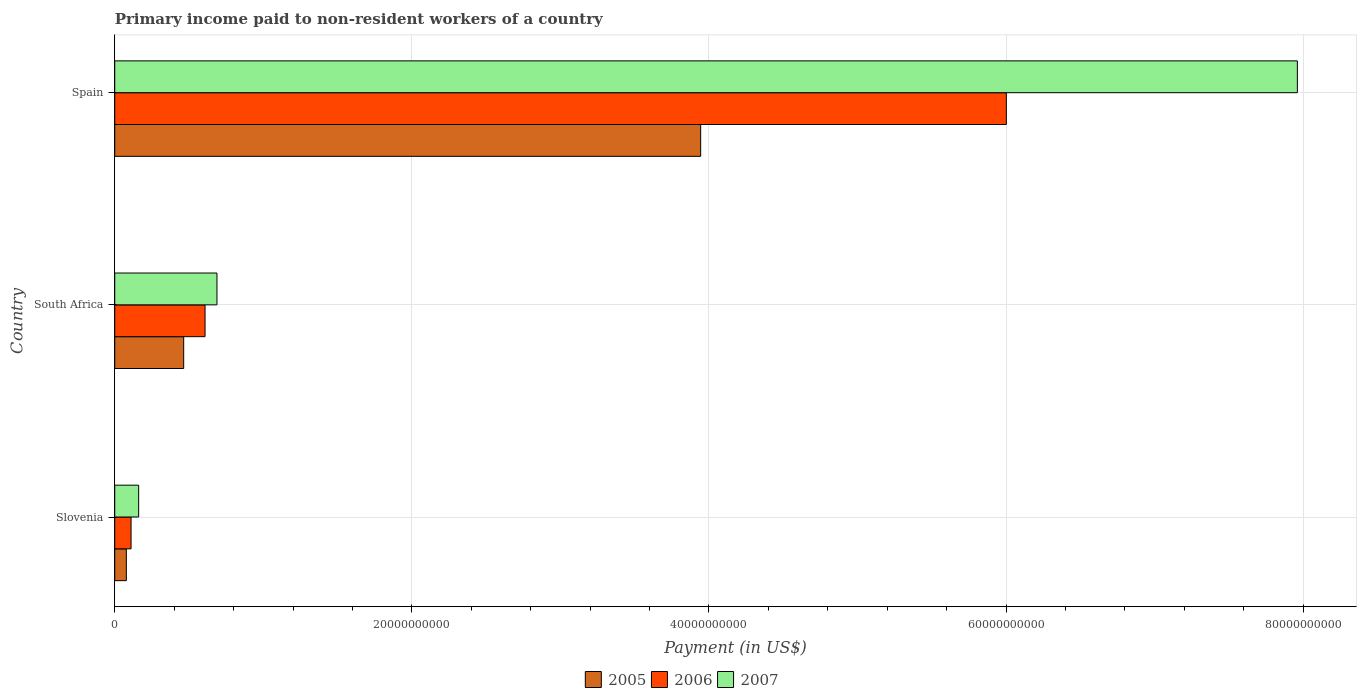How many different coloured bars are there?
Your answer should be very brief. 3. How many groups of bars are there?
Your answer should be very brief. 3. Are the number of bars per tick equal to the number of legend labels?
Offer a terse response. Yes. How many bars are there on the 3rd tick from the top?
Provide a succinct answer. 3. How many bars are there on the 3rd tick from the bottom?
Keep it short and to the point. 3. What is the label of the 2nd group of bars from the top?
Give a very brief answer. South Africa. What is the amount paid to workers in 2005 in South Africa?
Offer a terse response. 4.64e+09. Across all countries, what is the maximum amount paid to workers in 2007?
Keep it short and to the point. 7.96e+1. Across all countries, what is the minimum amount paid to workers in 2007?
Provide a short and direct response. 1.61e+09. In which country was the amount paid to workers in 2007 maximum?
Offer a very short reply. Spain. In which country was the amount paid to workers in 2006 minimum?
Ensure brevity in your answer.  Slovenia. What is the total amount paid to workers in 2005 in the graph?
Offer a very short reply. 4.49e+1. What is the difference between the amount paid to workers in 2005 in Slovenia and that in South Africa?
Your response must be concise. -3.86e+09. What is the difference between the amount paid to workers in 2005 in Spain and the amount paid to workers in 2007 in South Africa?
Give a very brief answer. 3.26e+1. What is the average amount paid to workers in 2006 per country?
Ensure brevity in your answer.  2.24e+1. What is the difference between the amount paid to workers in 2006 and amount paid to workers in 2005 in South Africa?
Keep it short and to the point. 1.44e+09. What is the ratio of the amount paid to workers in 2007 in Slovenia to that in Spain?
Provide a succinct answer. 0.02. Is the amount paid to workers in 2007 in South Africa less than that in Spain?
Your answer should be compact. Yes. What is the difference between the highest and the second highest amount paid to workers in 2005?
Offer a very short reply. 3.48e+1. What is the difference between the highest and the lowest amount paid to workers in 2006?
Your response must be concise. 5.89e+1. Is it the case that in every country, the sum of the amount paid to workers in 2006 and amount paid to workers in 2007 is greater than the amount paid to workers in 2005?
Keep it short and to the point. Yes. How many countries are there in the graph?
Provide a succinct answer. 3. Are the values on the major ticks of X-axis written in scientific E-notation?
Make the answer very short. No. Does the graph contain any zero values?
Your answer should be compact. No. How many legend labels are there?
Your response must be concise. 3. What is the title of the graph?
Give a very brief answer. Primary income paid to non-resident workers of a country. What is the label or title of the X-axis?
Your answer should be compact. Payment (in US$). What is the label or title of the Y-axis?
Keep it short and to the point. Country. What is the Payment (in US$) of 2005 in Slovenia?
Give a very brief answer. 7.81e+08. What is the Payment (in US$) in 2006 in Slovenia?
Provide a succinct answer. 1.10e+09. What is the Payment (in US$) in 2007 in Slovenia?
Your answer should be very brief. 1.61e+09. What is the Payment (in US$) in 2005 in South Africa?
Your answer should be very brief. 4.64e+09. What is the Payment (in US$) in 2006 in South Africa?
Your answer should be very brief. 6.08e+09. What is the Payment (in US$) in 2007 in South Africa?
Provide a succinct answer. 6.88e+09. What is the Payment (in US$) in 2005 in Spain?
Your answer should be very brief. 3.94e+1. What is the Payment (in US$) in 2006 in Spain?
Your answer should be compact. 6.00e+1. What is the Payment (in US$) of 2007 in Spain?
Your response must be concise. 7.96e+1. Across all countries, what is the maximum Payment (in US$) of 2005?
Provide a succinct answer. 3.94e+1. Across all countries, what is the maximum Payment (in US$) of 2006?
Offer a terse response. 6.00e+1. Across all countries, what is the maximum Payment (in US$) of 2007?
Give a very brief answer. 7.96e+1. Across all countries, what is the minimum Payment (in US$) of 2005?
Ensure brevity in your answer.  7.81e+08. Across all countries, what is the minimum Payment (in US$) in 2006?
Provide a short and direct response. 1.10e+09. Across all countries, what is the minimum Payment (in US$) of 2007?
Provide a short and direct response. 1.61e+09. What is the total Payment (in US$) in 2005 in the graph?
Offer a very short reply. 4.49e+1. What is the total Payment (in US$) of 2006 in the graph?
Keep it short and to the point. 6.72e+1. What is the total Payment (in US$) in 2007 in the graph?
Your answer should be compact. 8.81e+1. What is the difference between the Payment (in US$) in 2005 in Slovenia and that in South Africa?
Ensure brevity in your answer.  -3.86e+09. What is the difference between the Payment (in US$) of 2006 in Slovenia and that in South Africa?
Offer a terse response. -4.98e+09. What is the difference between the Payment (in US$) in 2007 in Slovenia and that in South Africa?
Make the answer very short. -5.27e+09. What is the difference between the Payment (in US$) of 2005 in Slovenia and that in Spain?
Give a very brief answer. -3.87e+1. What is the difference between the Payment (in US$) in 2006 in Slovenia and that in Spain?
Offer a very short reply. -5.89e+1. What is the difference between the Payment (in US$) of 2007 in Slovenia and that in Spain?
Offer a very short reply. -7.80e+1. What is the difference between the Payment (in US$) in 2005 in South Africa and that in Spain?
Offer a very short reply. -3.48e+1. What is the difference between the Payment (in US$) of 2006 in South Africa and that in Spain?
Your response must be concise. -5.39e+1. What is the difference between the Payment (in US$) of 2007 in South Africa and that in Spain?
Make the answer very short. -7.27e+1. What is the difference between the Payment (in US$) of 2005 in Slovenia and the Payment (in US$) of 2006 in South Africa?
Your response must be concise. -5.30e+09. What is the difference between the Payment (in US$) of 2005 in Slovenia and the Payment (in US$) of 2007 in South Africa?
Give a very brief answer. -6.10e+09. What is the difference between the Payment (in US$) in 2006 in Slovenia and the Payment (in US$) in 2007 in South Africa?
Give a very brief answer. -5.78e+09. What is the difference between the Payment (in US$) in 2005 in Slovenia and the Payment (in US$) in 2006 in Spain?
Your answer should be very brief. -5.92e+1. What is the difference between the Payment (in US$) in 2005 in Slovenia and the Payment (in US$) in 2007 in Spain?
Make the answer very short. -7.88e+1. What is the difference between the Payment (in US$) in 2006 in Slovenia and the Payment (in US$) in 2007 in Spain?
Provide a succinct answer. -7.85e+1. What is the difference between the Payment (in US$) in 2005 in South Africa and the Payment (in US$) in 2006 in Spain?
Make the answer very short. -5.54e+1. What is the difference between the Payment (in US$) in 2005 in South Africa and the Payment (in US$) in 2007 in Spain?
Give a very brief answer. -7.50e+1. What is the difference between the Payment (in US$) in 2006 in South Africa and the Payment (in US$) in 2007 in Spain?
Make the answer very short. -7.35e+1. What is the average Payment (in US$) in 2005 per country?
Provide a succinct answer. 1.50e+1. What is the average Payment (in US$) in 2006 per country?
Keep it short and to the point. 2.24e+1. What is the average Payment (in US$) in 2007 per country?
Make the answer very short. 2.94e+1. What is the difference between the Payment (in US$) in 2005 and Payment (in US$) in 2006 in Slovenia?
Your response must be concise. -3.17e+08. What is the difference between the Payment (in US$) of 2005 and Payment (in US$) of 2007 in Slovenia?
Your answer should be very brief. -8.29e+08. What is the difference between the Payment (in US$) in 2006 and Payment (in US$) in 2007 in Slovenia?
Provide a succinct answer. -5.12e+08. What is the difference between the Payment (in US$) in 2005 and Payment (in US$) in 2006 in South Africa?
Provide a succinct answer. -1.44e+09. What is the difference between the Payment (in US$) of 2005 and Payment (in US$) of 2007 in South Africa?
Offer a terse response. -2.24e+09. What is the difference between the Payment (in US$) in 2006 and Payment (in US$) in 2007 in South Africa?
Offer a terse response. -8.03e+08. What is the difference between the Payment (in US$) of 2005 and Payment (in US$) of 2006 in Spain?
Your response must be concise. -2.06e+1. What is the difference between the Payment (in US$) in 2005 and Payment (in US$) in 2007 in Spain?
Provide a short and direct response. -4.02e+1. What is the difference between the Payment (in US$) in 2006 and Payment (in US$) in 2007 in Spain?
Offer a terse response. -1.96e+1. What is the ratio of the Payment (in US$) of 2005 in Slovenia to that in South Africa?
Ensure brevity in your answer.  0.17. What is the ratio of the Payment (in US$) in 2006 in Slovenia to that in South Africa?
Give a very brief answer. 0.18. What is the ratio of the Payment (in US$) of 2007 in Slovenia to that in South Africa?
Provide a short and direct response. 0.23. What is the ratio of the Payment (in US$) of 2005 in Slovenia to that in Spain?
Offer a very short reply. 0.02. What is the ratio of the Payment (in US$) in 2006 in Slovenia to that in Spain?
Your answer should be very brief. 0.02. What is the ratio of the Payment (in US$) of 2007 in Slovenia to that in Spain?
Your answer should be compact. 0.02. What is the ratio of the Payment (in US$) in 2005 in South Africa to that in Spain?
Ensure brevity in your answer.  0.12. What is the ratio of the Payment (in US$) in 2006 in South Africa to that in Spain?
Give a very brief answer. 0.1. What is the ratio of the Payment (in US$) in 2007 in South Africa to that in Spain?
Give a very brief answer. 0.09. What is the difference between the highest and the second highest Payment (in US$) of 2005?
Your answer should be very brief. 3.48e+1. What is the difference between the highest and the second highest Payment (in US$) of 2006?
Keep it short and to the point. 5.39e+1. What is the difference between the highest and the second highest Payment (in US$) in 2007?
Keep it short and to the point. 7.27e+1. What is the difference between the highest and the lowest Payment (in US$) of 2005?
Make the answer very short. 3.87e+1. What is the difference between the highest and the lowest Payment (in US$) in 2006?
Give a very brief answer. 5.89e+1. What is the difference between the highest and the lowest Payment (in US$) of 2007?
Provide a short and direct response. 7.80e+1. 